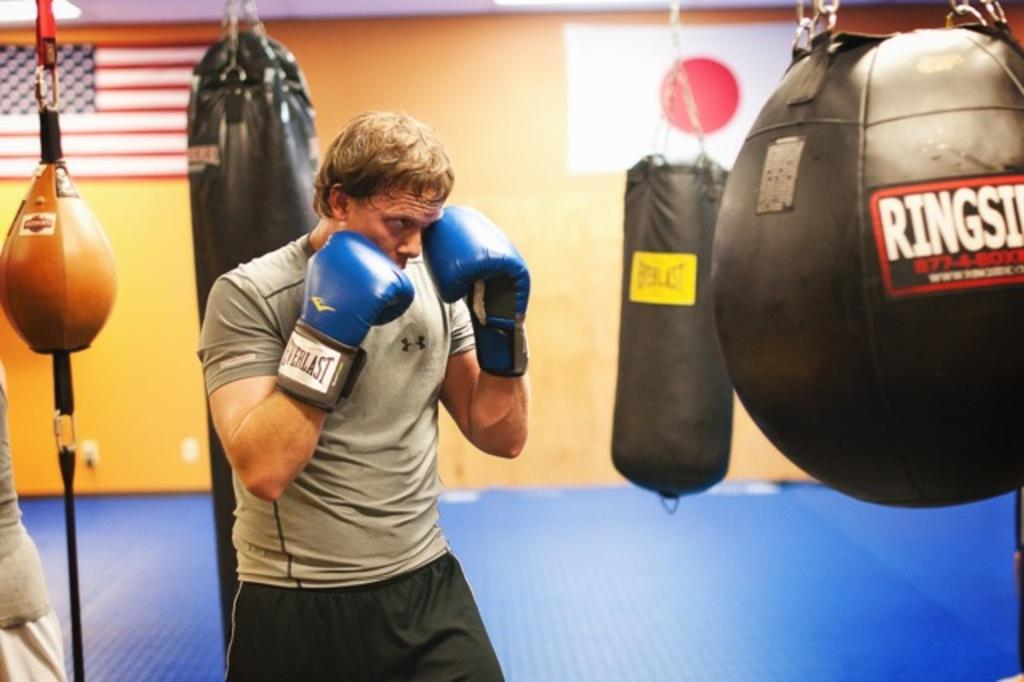<image>
Write a terse but informative summary of the picture. Everlast boxing glove and a ringside hitting ball in a gym. 